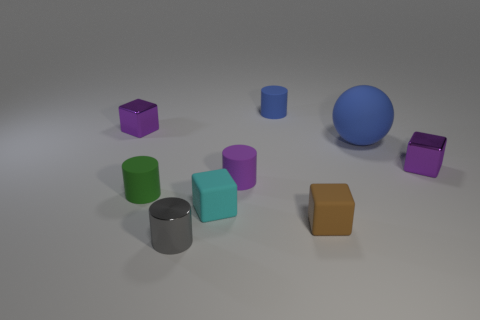Subtract all yellow blocks. Subtract all green cylinders. How many blocks are left? 4 Add 1 big things. How many objects exist? 10 Subtract all blocks. How many objects are left? 5 Add 6 gray shiny things. How many gray shiny things exist? 7 Subtract 0 cyan spheres. How many objects are left? 9 Subtract all tiny cylinders. Subtract all small cyan rubber spheres. How many objects are left? 5 Add 4 rubber objects. How many rubber objects are left? 10 